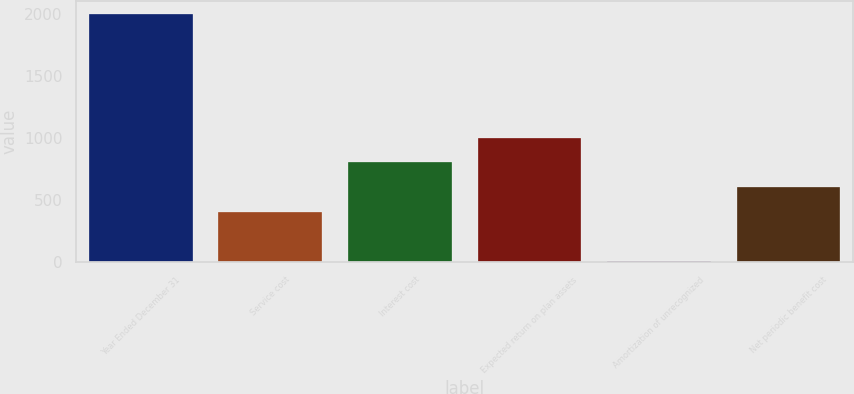Convert chart to OTSL. <chart><loc_0><loc_0><loc_500><loc_500><bar_chart><fcel>Year Ended December 31<fcel>Service cost<fcel>Interest cost<fcel>Expected return on plan assets<fcel>Amortization of unrecognized<fcel>Net periodic benefit cost<nl><fcel>2005<fcel>407<fcel>806.5<fcel>1006.25<fcel>7.5<fcel>606.75<nl></chart> 